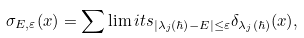<formula> <loc_0><loc_0><loc_500><loc_500>\sigma _ { E , \varepsilon } ( x ) = \sum \lim i t s _ { | \lambda _ { j } ( \hbar { ) } - E | \leq \varepsilon } \delta _ { \lambda _ { j } ( \hbar { ) } } ( x ) ,</formula> 